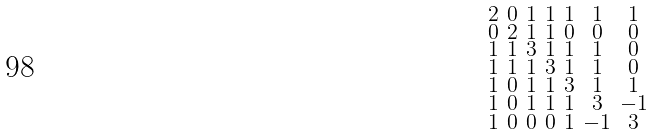<formula> <loc_0><loc_0><loc_500><loc_500>\begin{smallmatrix} 2 & 0 & 1 & 1 & 1 & 1 & 1 \\ 0 & 2 & 1 & 1 & 0 & 0 & 0 \\ 1 & 1 & 3 & 1 & 1 & 1 & 0 \\ 1 & 1 & 1 & 3 & 1 & 1 & 0 \\ 1 & 0 & 1 & 1 & 3 & 1 & 1 \\ 1 & 0 & 1 & 1 & 1 & 3 & - 1 \\ 1 & 0 & 0 & 0 & 1 & - 1 & 3 \end{smallmatrix}</formula> 